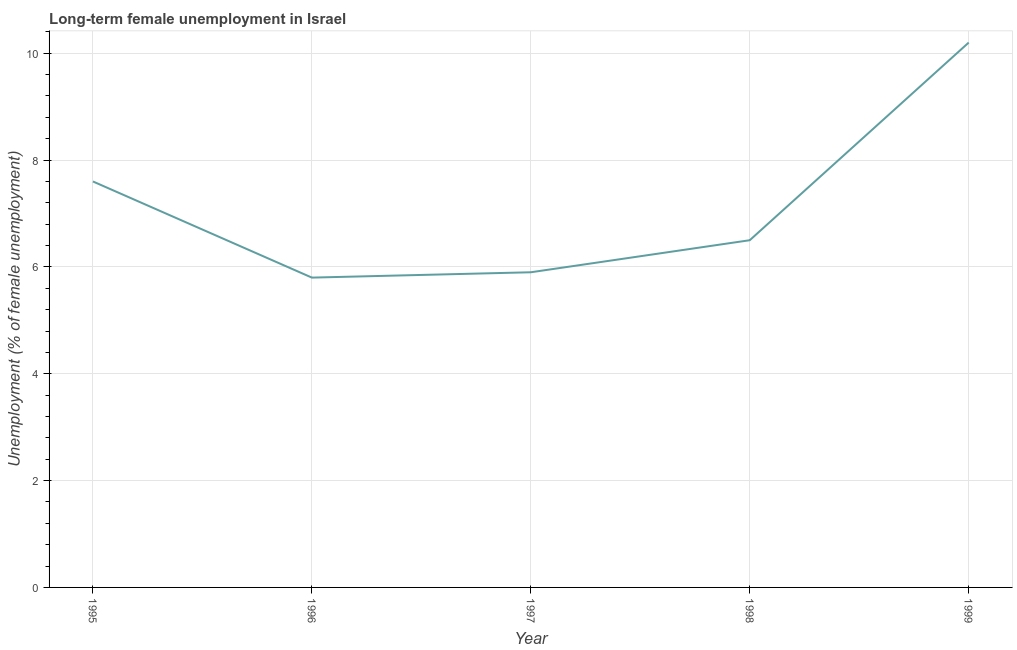What is the long-term female unemployment in 1996?
Offer a terse response. 5.8. Across all years, what is the maximum long-term female unemployment?
Provide a short and direct response. 10.2. Across all years, what is the minimum long-term female unemployment?
Give a very brief answer. 5.8. In which year was the long-term female unemployment maximum?
Ensure brevity in your answer.  1999. In which year was the long-term female unemployment minimum?
Your answer should be compact. 1996. What is the sum of the long-term female unemployment?
Give a very brief answer. 36. What is the difference between the long-term female unemployment in 1998 and 1999?
Provide a succinct answer. -3.7. What is the average long-term female unemployment per year?
Your answer should be very brief. 7.2. In how many years, is the long-term female unemployment greater than 7.2 %?
Keep it short and to the point. 2. Do a majority of the years between 1998 and 1999 (inclusive) have long-term female unemployment greater than 2.8 %?
Make the answer very short. Yes. What is the ratio of the long-term female unemployment in 1997 to that in 1998?
Offer a terse response. 0.91. What is the difference between the highest and the second highest long-term female unemployment?
Offer a terse response. 2.6. Is the sum of the long-term female unemployment in 1996 and 1999 greater than the maximum long-term female unemployment across all years?
Offer a terse response. Yes. What is the difference between the highest and the lowest long-term female unemployment?
Ensure brevity in your answer.  4.4. In how many years, is the long-term female unemployment greater than the average long-term female unemployment taken over all years?
Ensure brevity in your answer.  2. Does the graph contain any zero values?
Offer a terse response. No. Does the graph contain grids?
Provide a succinct answer. Yes. What is the title of the graph?
Ensure brevity in your answer.  Long-term female unemployment in Israel. What is the label or title of the Y-axis?
Your answer should be very brief. Unemployment (% of female unemployment). What is the Unemployment (% of female unemployment) in 1995?
Offer a terse response. 7.6. What is the Unemployment (% of female unemployment) in 1996?
Give a very brief answer. 5.8. What is the Unemployment (% of female unemployment) of 1997?
Your answer should be very brief. 5.9. What is the Unemployment (% of female unemployment) of 1998?
Your answer should be compact. 6.5. What is the Unemployment (% of female unemployment) in 1999?
Your response must be concise. 10.2. What is the difference between the Unemployment (% of female unemployment) in 1995 and 1996?
Your answer should be compact. 1.8. What is the difference between the Unemployment (% of female unemployment) in 1995 and 1997?
Offer a very short reply. 1.7. What is the difference between the Unemployment (% of female unemployment) in 1995 and 1998?
Your answer should be compact. 1.1. What is the difference between the Unemployment (% of female unemployment) in 1996 and 1999?
Your response must be concise. -4.4. What is the difference between the Unemployment (% of female unemployment) in 1997 and 1999?
Your response must be concise. -4.3. What is the difference between the Unemployment (% of female unemployment) in 1998 and 1999?
Your answer should be compact. -3.7. What is the ratio of the Unemployment (% of female unemployment) in 1995 to that in 1996?
Offer a very short reply. 1.31. What is the ratio of the Unemployment (% of female unemployment) in 1995 to that in 1997?
Give a very brief answer. 1.29. What is the ratio of the Unemployment (% of female unemployment) in 1995 to that in 1998?
Offer a very short reply. 1.17. What is the ratio of the Unemployment (% of female unemployment) in 1995 to that in 1999?
Keep it short and to the point. 0.74. What is the ratio of the Unemployment (% of female unemployment) in 1996 to that in 1998?
Offer a terse response. 0.89. What is the ratio of the Unemployment (% of female unemployment) in 1996 to that in 1999?
Make the answer very short. 0.57. What is the ratio of the Unemployment (% of female unemployment) in 1997 to that in 1998?
Your answer should be very brief. 0.91. What is the ratio of the Unemployment (% of female unemployment) in 1997 to that in 1999?
Ensure brevity in your answer.  0.58. What is the ratio of the Unemployment (% of female unemployment) in 1998 to that in 1999?
Ensure brevity in your answer.  0.64. 